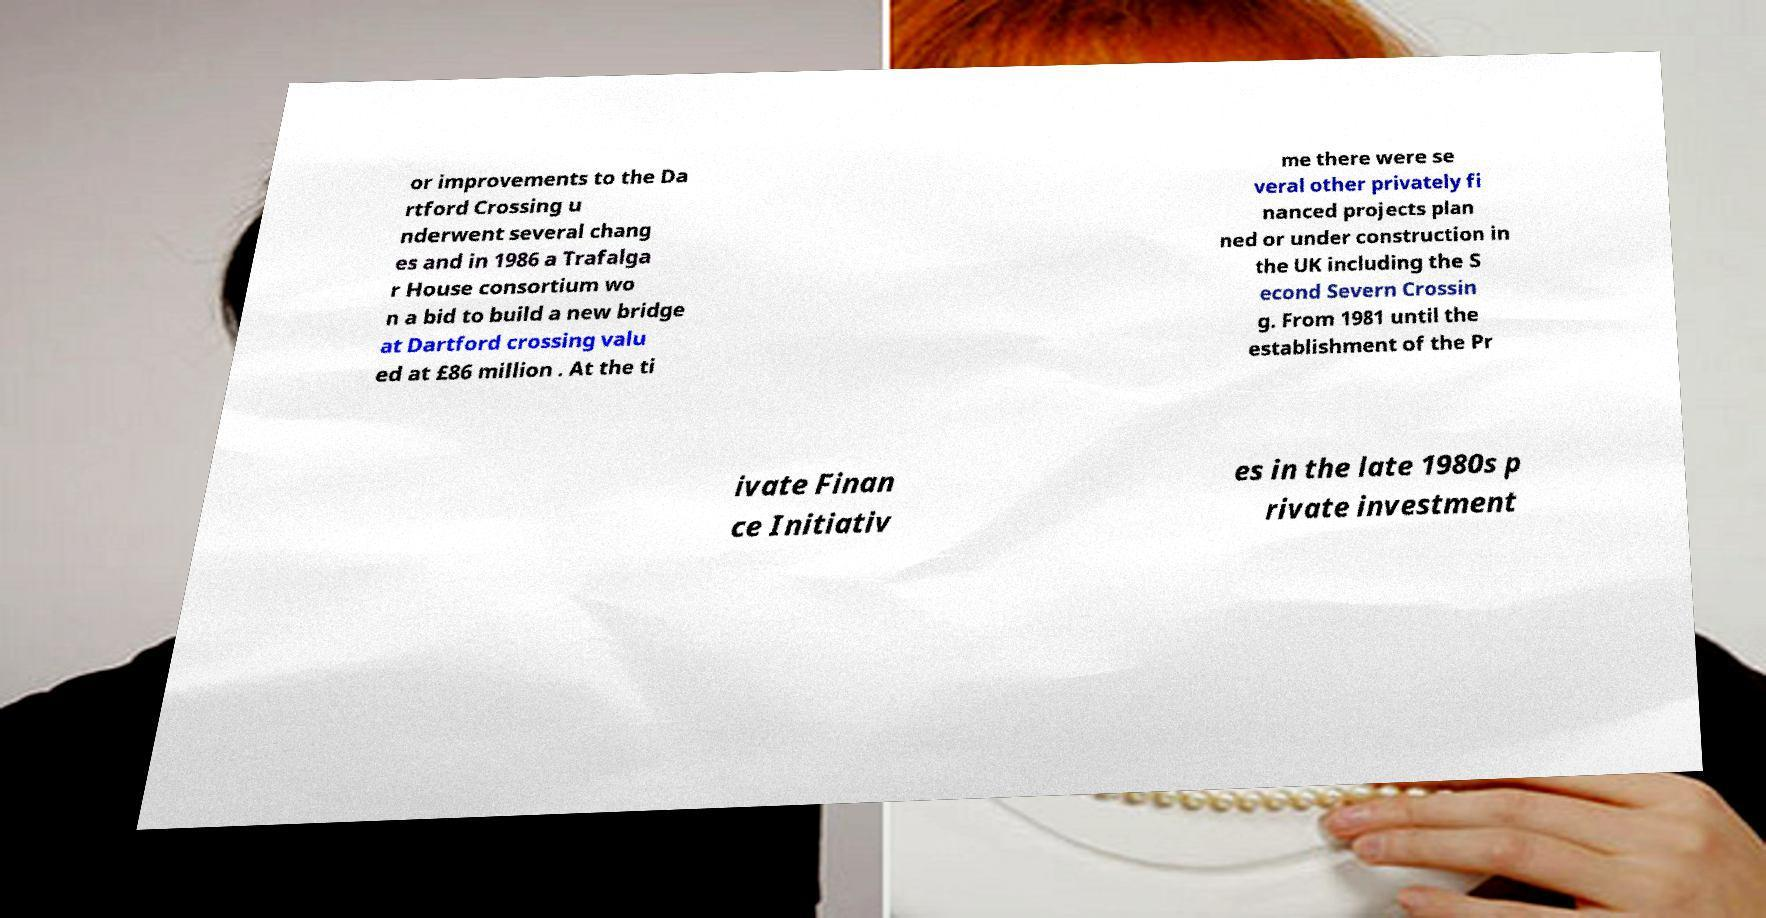There's text embedded in this image that I need extracted. Can you transcribe it verbatim? or improvements to the Da rtford Crossing u nderwent several chang es and in 1986 a Trafalga r House consortium wo n a bid to build a new bridge at Dartford crossing valu ed at £86 million . At the ti me there were se veral other privately fi nanced projects plan ned or under construction in the UK including the S econd Severn Crossin g. From 1981 until the establishment of the Pr ivate Finan ce Initiativ es in the late 1980s p rivate investment 